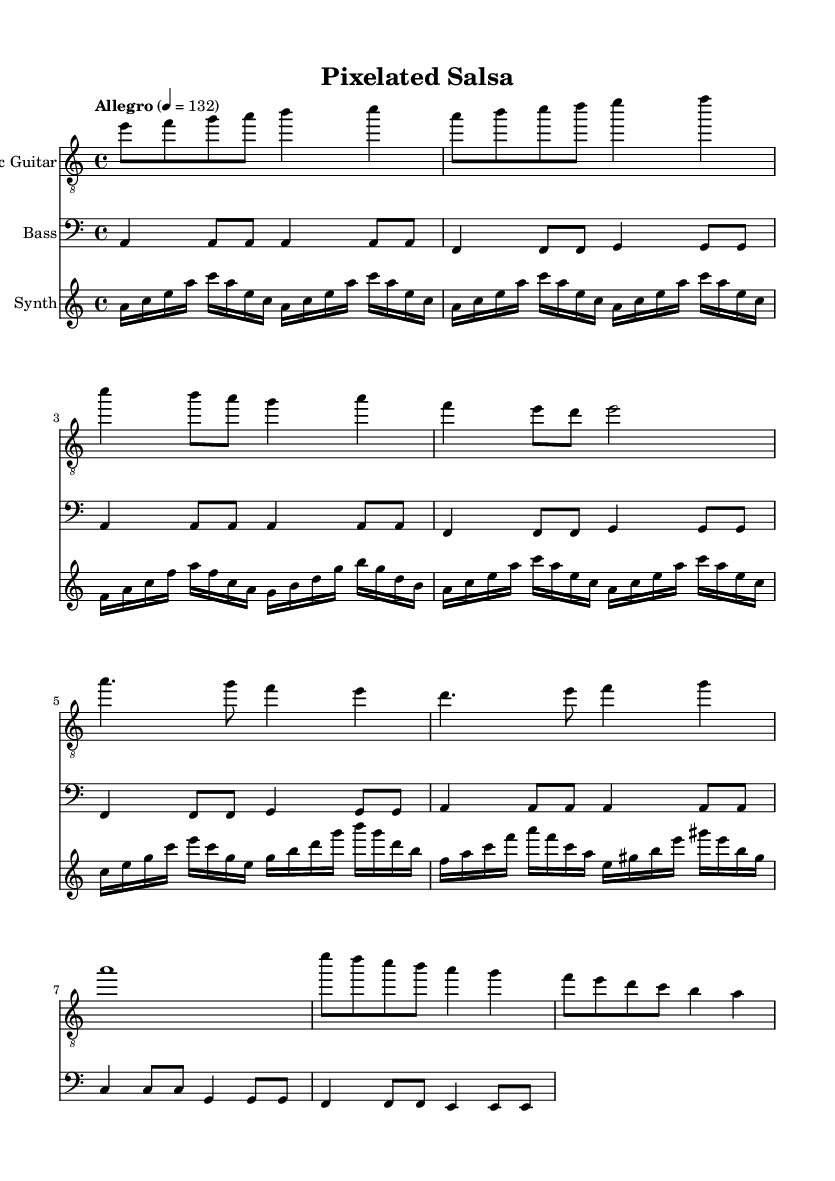What is the key signature of this music? The key signature is indicated in the first measure, where it shows one flat for the key of A minor.
Answer: A minor What is the time signature of the piece? The time signature is found at the beginning of the music, displaying a 4/4 meter, meaning there are four beats in each bar.
Answer: 4/4 What is the tempo marking for this piece? The tempo marking is located at the beginning, stating "Allegro" with a metronome marking of 132 beats per minute, indicating a fast pace.
Answer: Allegro 4 = 132 What is the highest note played by the electric guitar? The electric guitar part shows the highest note being played is an "b" which appears in several measures, mainly during the chorus sections.
Answer: b How many distinct sections are present in the music? By analyzing the structure, we can identify the separated parts labeled as Intro, Verse, Chorus, and Bridge, leading to a total of four distinct sections.
Answer: 4 What is the primary function of the synth in this piece? The synth provides harmonic support and texture throughout, as indicated by its repeated melodic phrases and rhythm that complements the rhythm section.
Answer: Harmonic support 